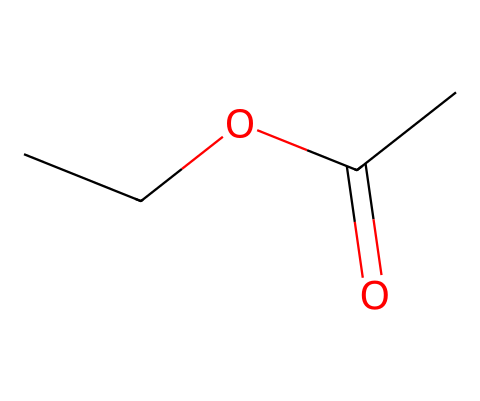What is the molecular formula of ethyl acetate? The molecular formula can be derived from the SMILES representation. In this case, CC(=O)OCC indicates that there are two carbon chains (C) contributing to the total, along with the carboxyl functional group (COO), so C4H8O2 is the molecular formula.
Answer: C4H8O2 How many carbon atoms are present in ethyl acetate? By examining the SMILES, we count the number of carbon atoms represented: two from the ethyl group (CC) and two from the acetate group (C(=O)O), resulting in four total carbon atoms.
Answer: four What functional group is present in ethyl acetate? The functional group can be identified in the structure; the presence of the carbonyl group (C=O) attached to an ether (R-O-R) indicates it is an ester.
Answer: ester What is the degree of unsaturation in ethyl acetate? To find the degree of unsaturation, we consider the number of rings or multiple bonds. In this case, the carbonyl (C=O) provides one degree of unsaturation, and there are no other double bonds or rings present in the SMILES structure, leading to a degree of one.
Answer: one What type of solvent is ethyl acetate considered? Ethyl acetate is known for its ability to dissolve both polar and nonpolar substances, making it a versatile solvent, often categorized as a polar aprotic solvent.
Answer: polar aprotic Which part of the structure is responsible for the solvent properties of ethyl acetate? The ethyl group (OCC) provides the hydrophobic character, while the ester functional group contributes to polar interactions, making this combination responsible for its effective solvent properties.
Answer: ethyl group and ester functional group 